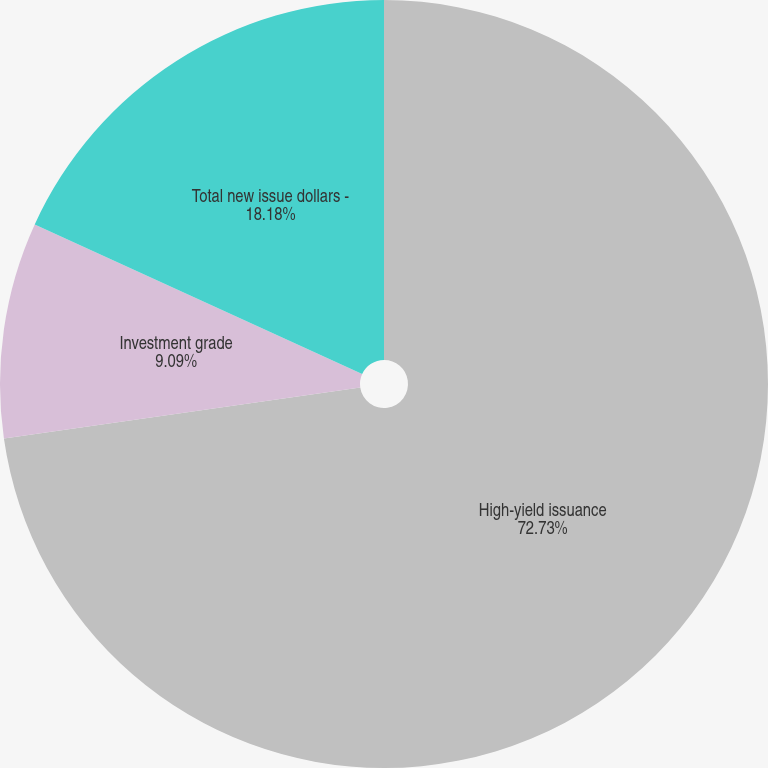Convert chart. <chart><loc_0><loc_0><loc_500><loc_500><pie_chart><fcel>High-yield issuance<fcel>Investment grade<fcel>Total new issue dollars -<nl><fcel>72.73%<fcel>9.09%<fcel>18.18%<nl></chart> 